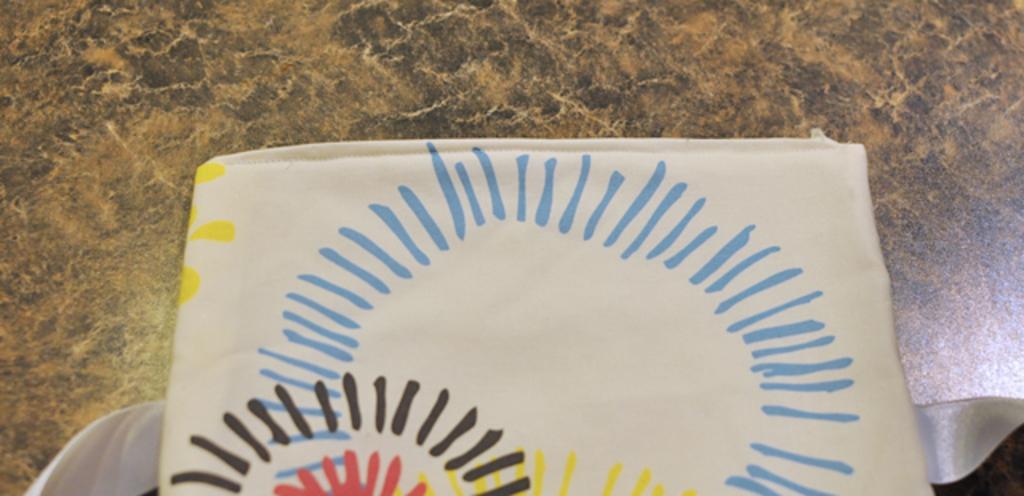In one or two sentences, can you explain what this image depicts? In this image we can see cloth on the floor. 